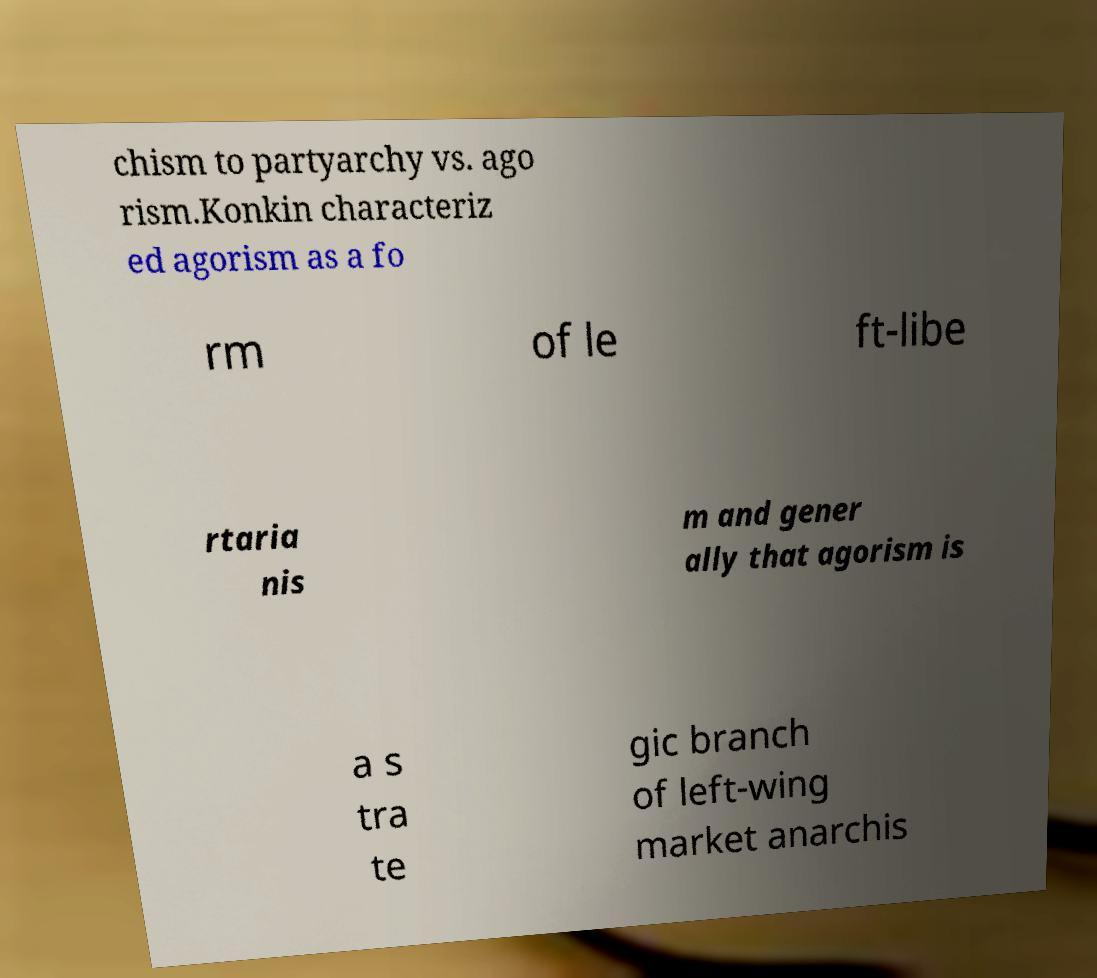Could you extract and type out the text from this image? chism to partyarchy vs. ago rism.Konkin characteriz ed agorism as a fo rm of le ft-libe rtaria nis m and gener ally that agorism is a s tra te gic branch of left-wing market anarchis 